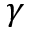Convert formula to latex. <formula><loc_0><loc_0><loc_500><loc_500>\gamma</formula> 